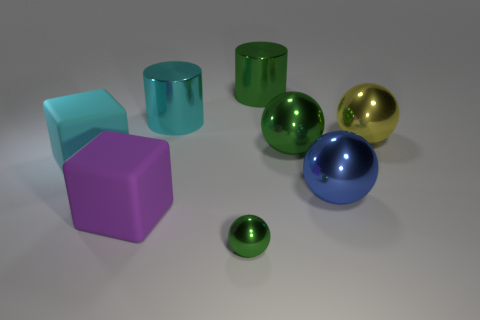Subtract all large green spheres. How many spheres are left? 3 Subtract all yellow spheres. How many spheres are left? 3 Subtract all purple spheres. Subtract all cyan blocks. How many spheres are left? 4 Add 1 gray metallic objects. How many objects exist? 9 Subtract all cylinders. How many objects are left? 6 Add 6 big purple objects. How many big purple objects exist? 7 Subtract 1 cyan blocks. How many objects are left? 7 Subtract all small purple rubber balls. Subtract all yellow shiny balls. How many objects are left? 7 Add 7 big cyan rubber blocks. How many big cyan rubber blocks are left? 8 